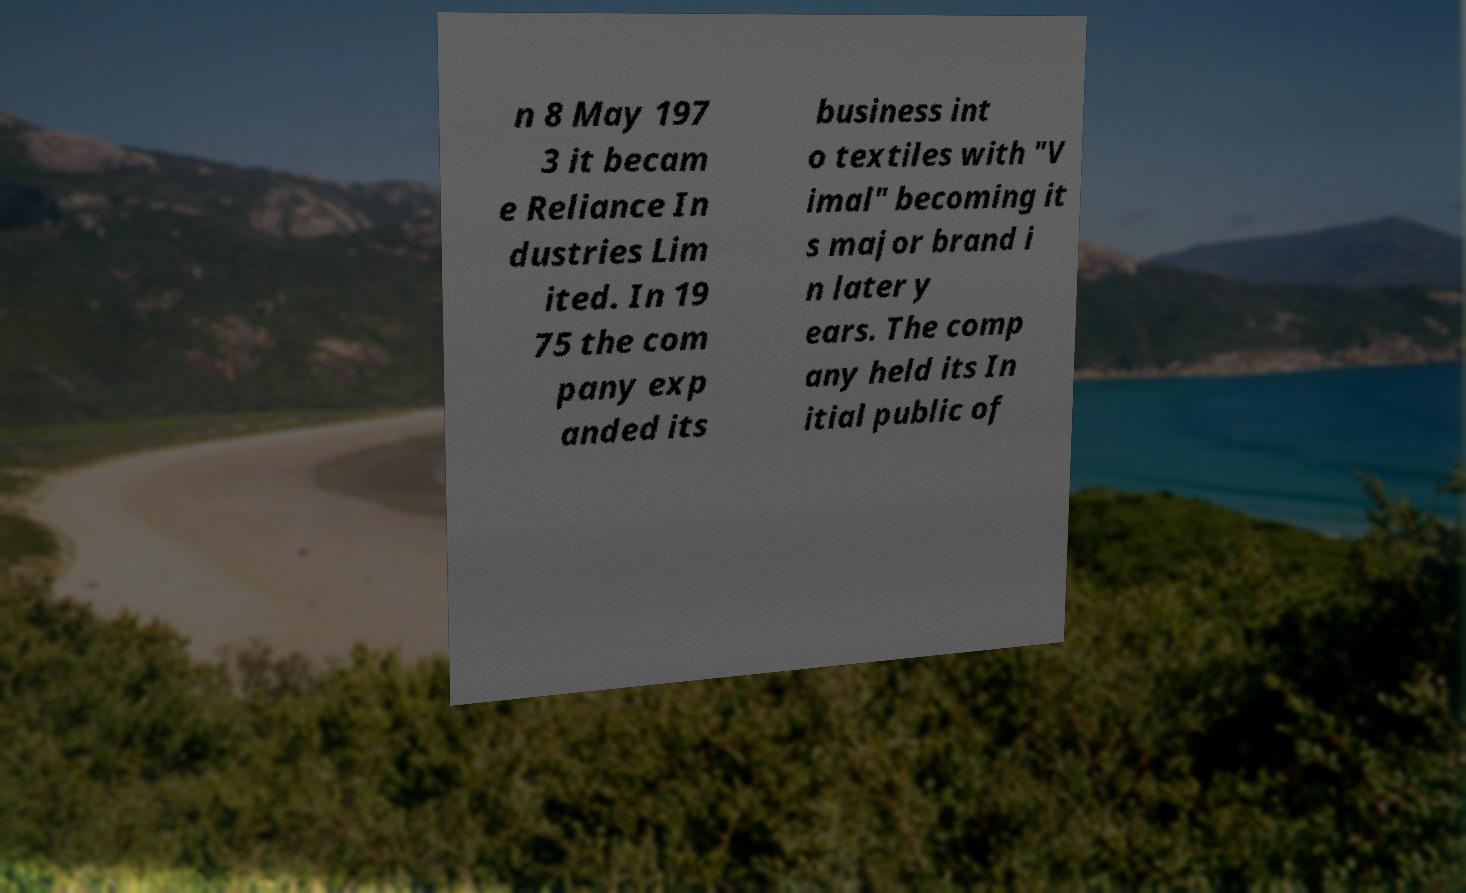What messages or text are displayed in this image? I need them in a readable, typed format. n 8 May 197 3 it becam e Reliance In dustries Lim ited. In 19 75 the com pany exp anded its business int o textiles with "V imal" becoming it s major brand i n later y ears. The comp any held its In itial public of 